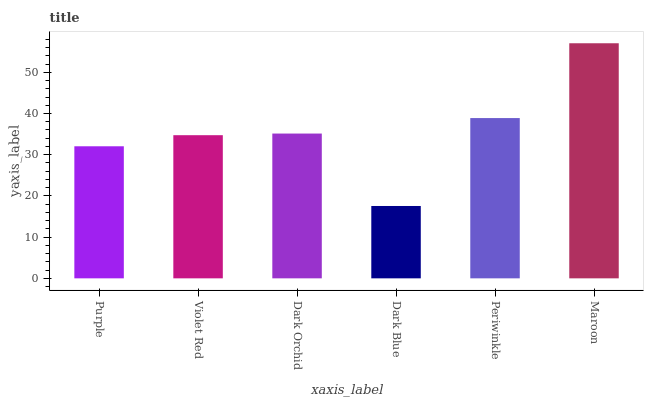Is Dark Blue the minimum?
Answer yes or no. Yes. Is Maroon the maximum?
Answer yes or no. Yes. Is Violet Red the minimum?
Answer yes or no. No. Is Violet Red the maximum?
Answer yes or no. No. Is Violet Red greater than Purple?
Answer yes or no. Yes. Is Purple less than Violet Red?
Answer yes or no. Yes. Is Purple greater than Violet Red?
Answer yes or no. No. Is Violet Red less than Purple?
Answer yes or no. No. Is Dark Orchid the high median?
Answer yes or no. Yes. Is Violet Red the low median?
Answer yes or no. Yes. Is Purple the high median?
Answer yes or no. No. Is Purple the low median?
Answer yes or no. No. 